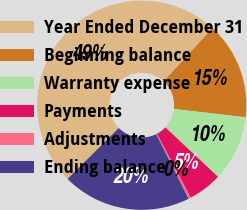Convert chart. <chart><loc_0><loc_0><loc_500><loc_500><pie_chart><fcel>Year Ended December 31<fcel>Beginning balance<fcel>Warranty expense<fcel>Payments<fcel>Adjustments<fcel>Ending balance<nl><fcel>49.27%<fcel>15.04%<fcel>10.15%<fcel>5.26%<fcel>0.37%<fcel>19.93%<nl></chart> 